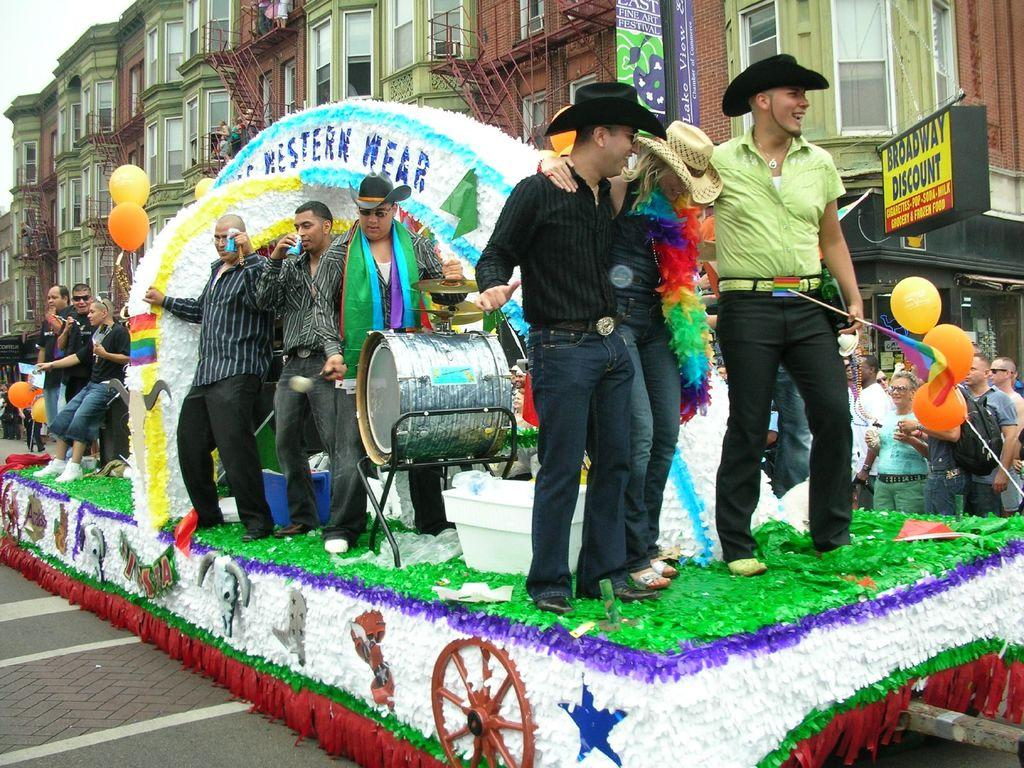What are the people in the image doing on the vehicle? Some of the people are playing musical instruments. Can you describe the background of the image? There are buildings in the background of the image. What type of pot is being used by the people on the vehicle? There is no pot present in the image; the people are playing musical instruments on a vehicle. What is the purpose of the toothbrush in the image? There is no toothbrush present in the image. 